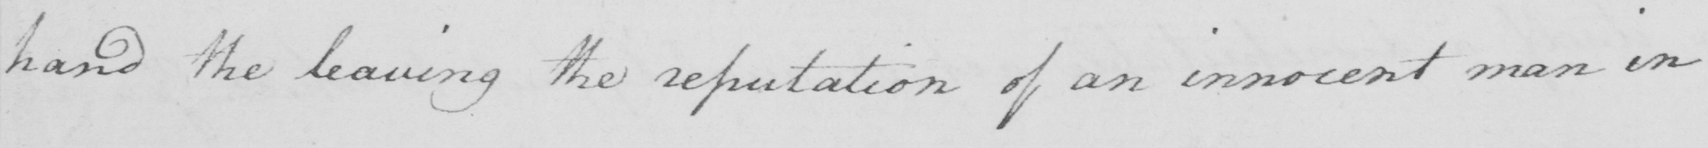Transcribe the text shown in this historical manuscript line. hand the leaving the reputation of an innocent man in 